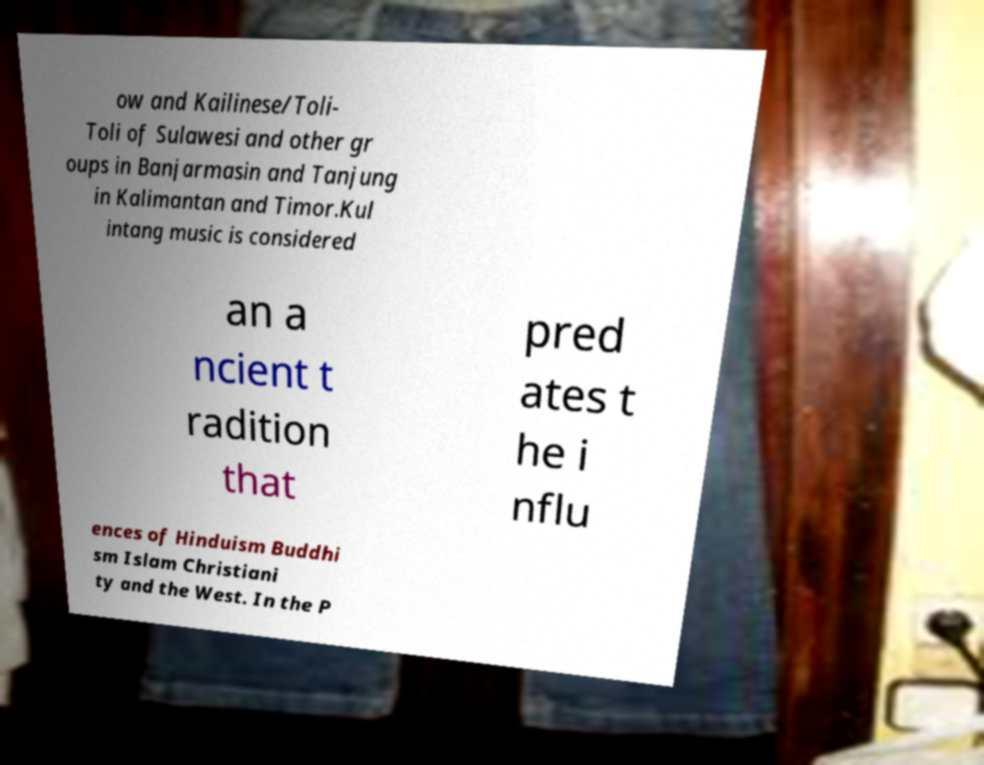Could you extract and type out the text from this image? ow and Kailinese/Toli- Toli of Sulawesi and other gr oups in Banjarmasin and Tanjung in Kalimantan and Timor.Kul intang music is considered an a ncient t radition that pred ates t he i nflu ences of Hinduism Buddhi sm Islam Christiani ty and the West. In the P 